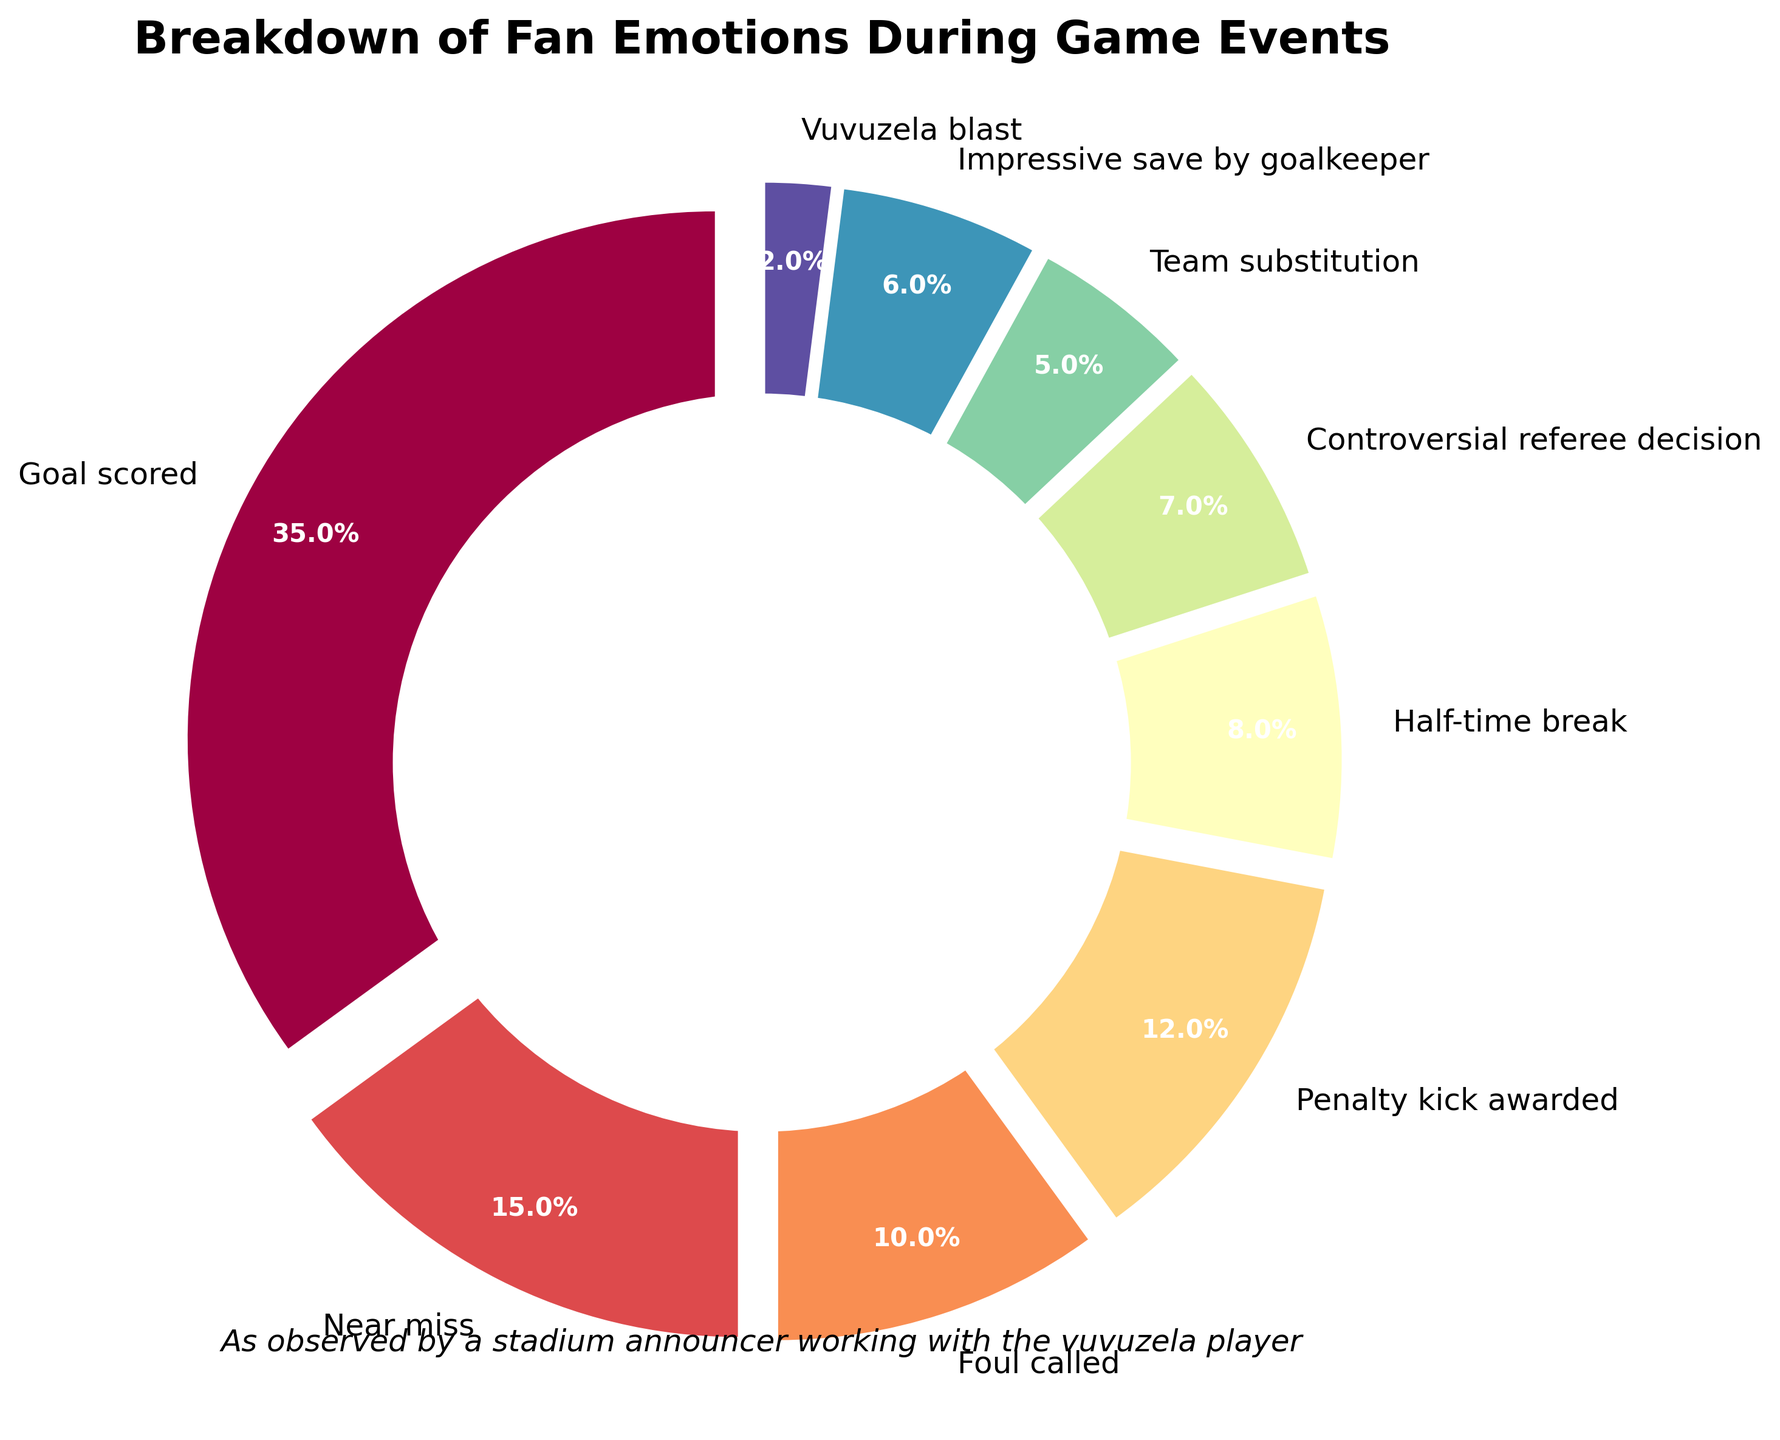Which event has the highest percentage of fan emotions? The event with the largest wedge in the pie chart represents the highest percentage. Here, the "Goal scored" has the biggest section, corresponding to 35%.
Answer: Goal scored Compare the fan emotions for a goal scored vs. a near miss. Which one is higher, and by how much? The "Goal scored" section indicates 35%, while the "Near miss" section shows 15%. The difference is calculated as 35% - 15% = 20%.
Answer: Goal scored by 20% What is the total percentage of fan emotions during foul-related events ("Foul called" and "Controversial referee decision")? Add the percentages for "Foul called" (10%) and "Controversial referee decision" (7%). 10% + 7% = 17%.
Answer: 17% Which event related to goalkeeping has the least percentage of fan emotions, and what is that percentage? Compare the percentages for events involving goalkeeping: "Penalty kick awarded" (12%) and "Impressive save by goalkeeper" (6%). The "Impressive save by goalkeeper" has the lowest percentage of 6%.
Answer: Impressive save by goalkeeper, 6% How much higher is the percentage of emotions during a penalty kick awarded compared to a team substitution? Check the percentages for "Penalty kick awarded" (12%) and "Team substitution" (5%). Subtract the smaller percentage from the larger one: 12% - 5% = 7%.
Answer: 7% Which visual characteristic stands out for the sections representing "Half-time break" and "Vuvuzela blast"? The chunks for "Half-time break" and "Vuvuzela blast" are relatively insignificant and smaller compared to others due to their lower percentages (8% and 2%, respectively).
Answer: Smaller size What is the total percentage of fan emotions during team-specific events (subtract the "Vuvuzela blast")? Sum the percentages of all events excluding "Vuvuzela blast": 35% + 15% + 10% + 12% + 8% + 7% + 5% + 6% = 98%.
Answer: 98% Rank the top three events with the highest percentage of fan emotions. Identify the top three highest percentages: 1. "Goal scored" (35%), 2. "Near miss" (15%), 3. "Penalty kick awarded" (12%).
Answer: Goal scored, Near miss, Penalty kick awarded What is the combined percentage of fan emotions during the "Half-time break" and "Vuvuzela blast"? Add the percentages: "Half-time break" (8%) and "Vuvuzela blast" (2%). 8% + 2% = 10%.
Answer: 10% 